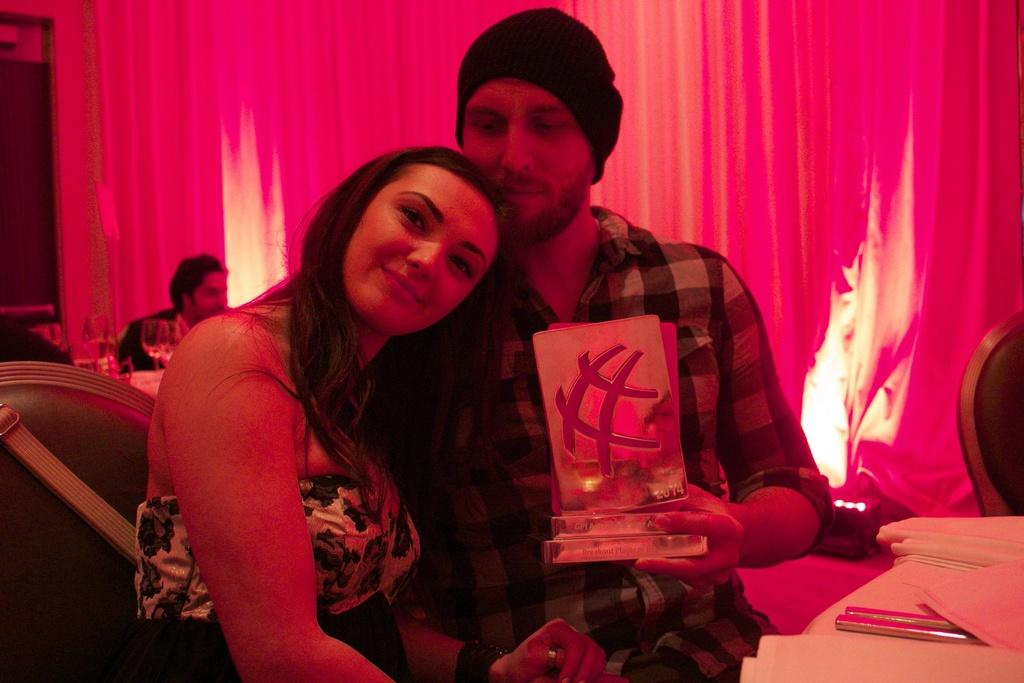How many people are present in the image? There are two people, a man and a woman, present in the image. What are the man and woman doing in the image? Both the man and woman are sitting. What are the man and woman wearing in the image? The man and woman are wearing clothes. What objects can be seen in the image related to seating? There is a chair in the image. What objects can be seen in the image related to drinking? There are wine glasses in the image. What objects can be seen in the image related to clothing? There is a cap in the image. What objects can be seen in the image related to covering or decoration? There is a cloth object and curtains in the image. How many additional people are present in the image? There are two people sitting behind the man and woman. How many clams are visible in the image? There are no clams present in the image. What type of cows can be seen grazing in the background of the image? There are no cows present in the image. 